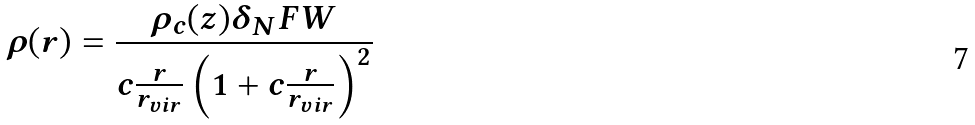Convert formula to latex. <formula><loc_0><loc_0><loc_500><loc_500>\rho ( r ) = \frac { \rho _ { c } ( z ) \delta _ { N } F W } { c \frac { r } { r _ { v i r } } \left ( 1 + c \frac { r } { r _ { v i r } } \right ) ^ { 2 } }</formula> 